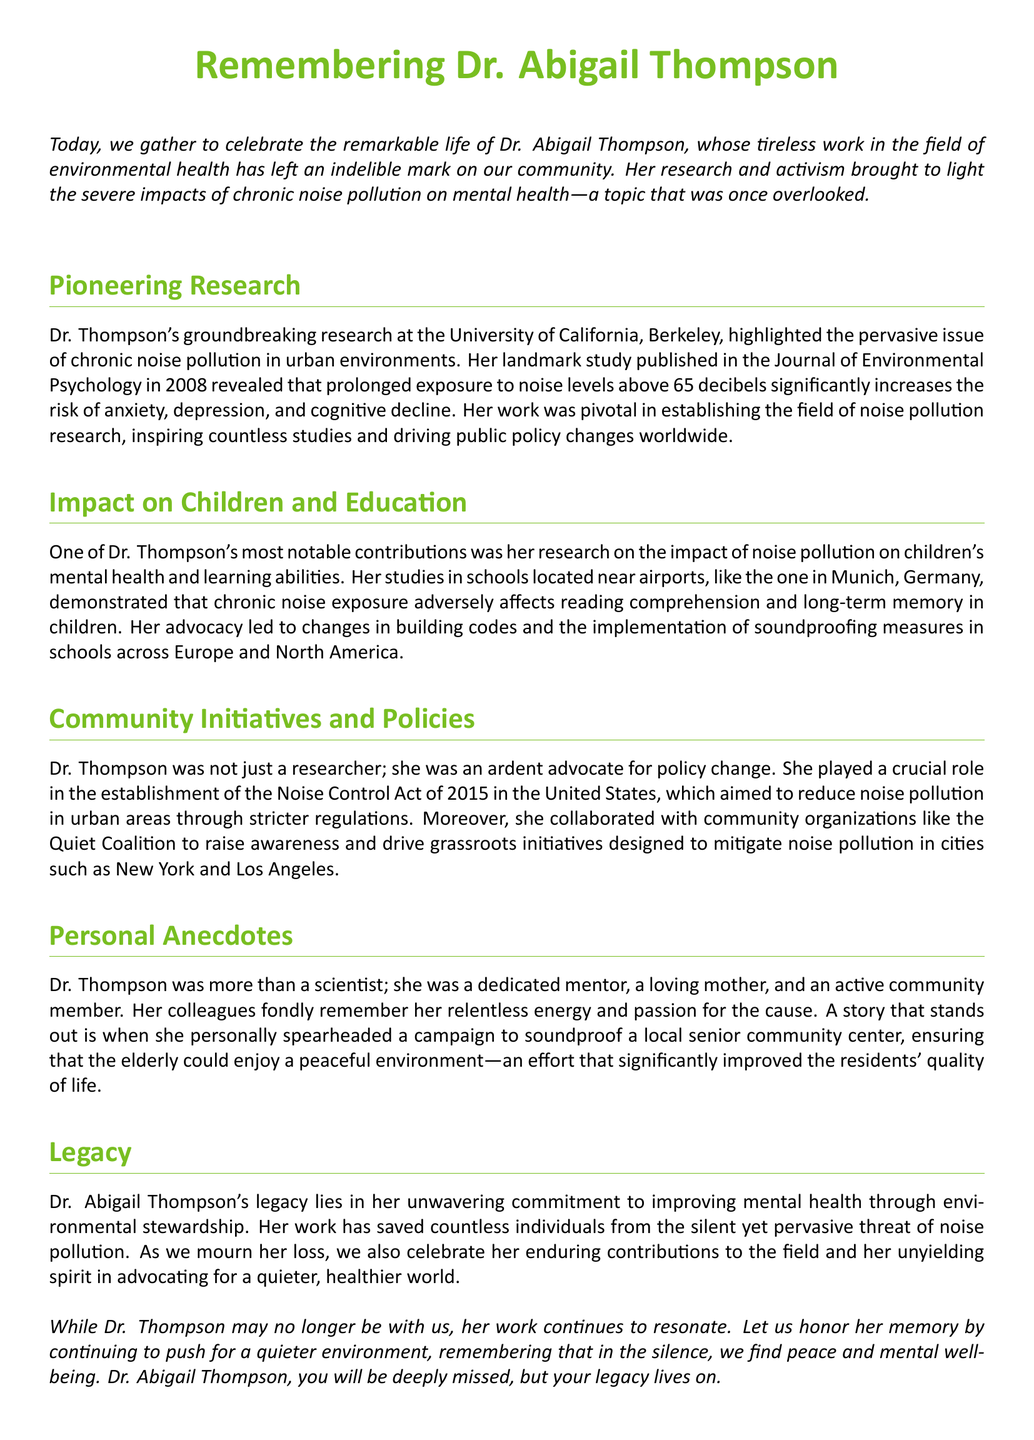What was Dr. Abigail Thompson's profession? The document identifies Dr. Abigail Thompson as a researcher in the field of environmental health.
Answer: researcher What year was the Noise Control Act established? The document states that the Noise Control Act was established in 2015.
Answer: 2015 What was the focus of Dr. Thompson's landmark study published in 2008? The study published in 2008 focused on the impacts of prolonged exposure to noise levels above 65 decibels on mental health.
Answer: mental health Which community organization did Dr. Thompson collaborate with? The document mentions her collaboration with the Quiet Coalition.
Answer: Quiet Coalition What significant impact did noise pollution have on children's education, according to Dr. Thompson's research? Her research showed that chronic noise exposure adversely affects reading comprehension and long-term memory in children.
Answer: reading comprehension How did Dr. Thompson contribute to improving community quality of life? She spearheaded a campaign to soundproof a local senior community center, which significantly improved the residents' quality of life.
Answer: soundproofing What location was specifically mentioned in relation to her studies on noise pollution? The document mentions studies conducted in schools located near airports, such as in Munich, Germany.
Answer: Munich What was a key result of Dr. Thompson's advocacy for schools? Her advocacy led to changes in building codes and implementation of soundproofing measures in schools.
Answer: soundproofing measures What is described as an aspect of Dr. Thompson's legacy? The document states that her legacy lies in improving mental health through environmental stewardship.
Answer: improving mental health 